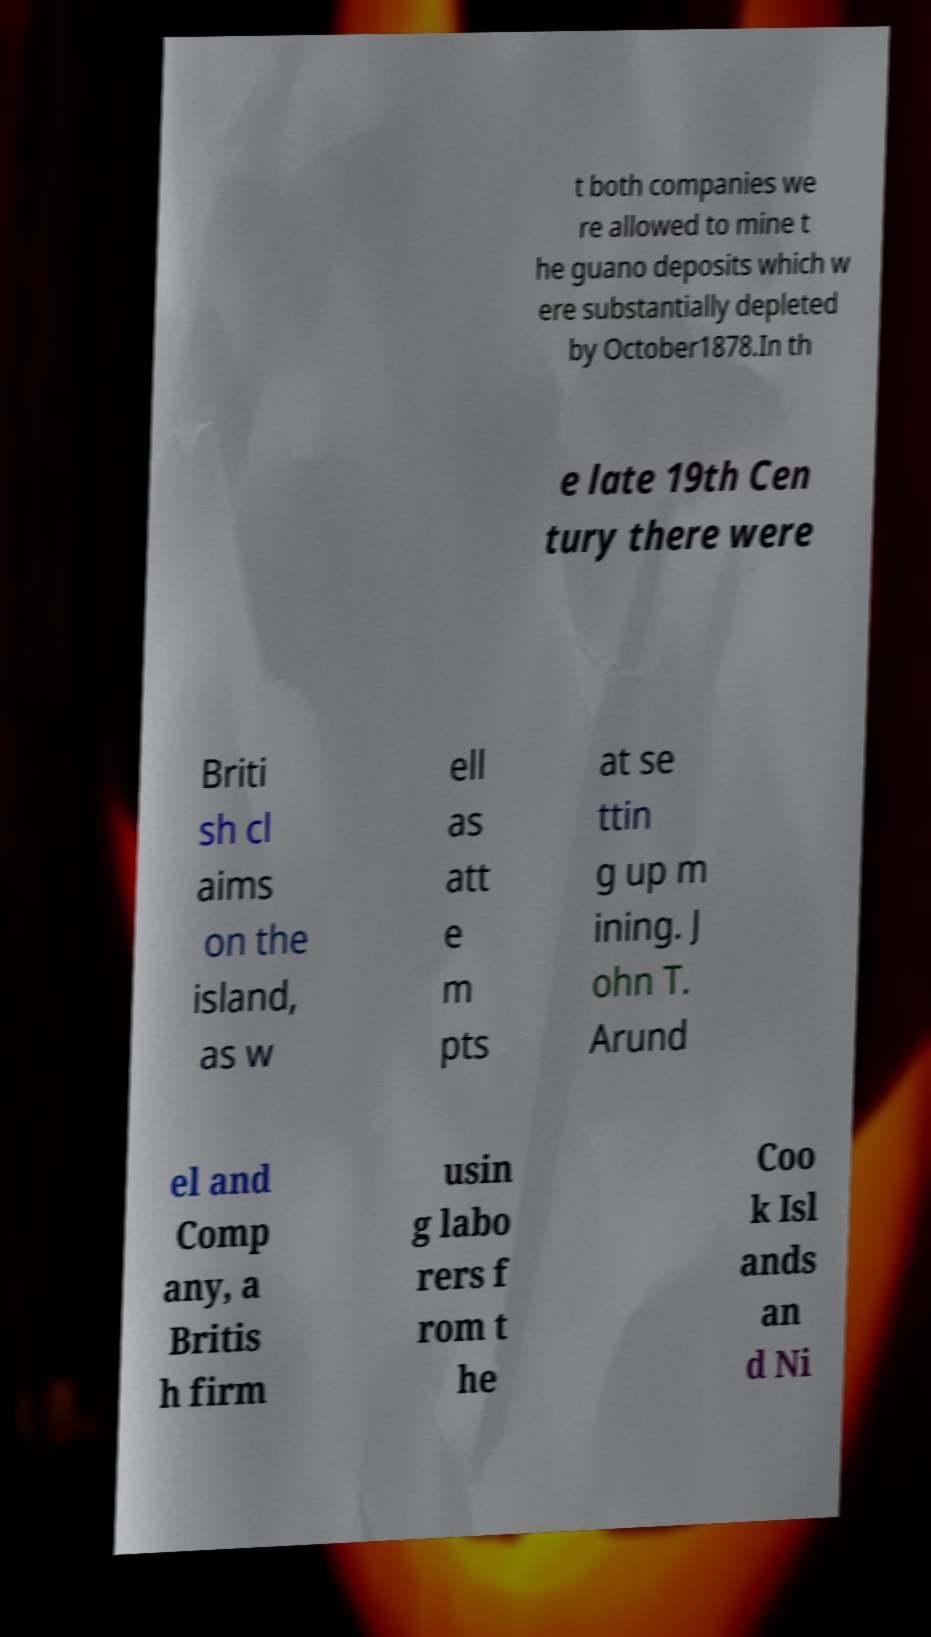Please identify and transcribe the text found in this image. t both companies we re allowed to mine t he guano deposits which w ere substantially depleted by October1878.In th e late 19th Cen tury there were Briti sh cl aims on the island, as w ell as att e m pts at se ttin g up m ining. J ohn T. Arund el and Comp any, a Britis h firm usin g labo rers f rom t he Coo k Isl ands an d Ni 